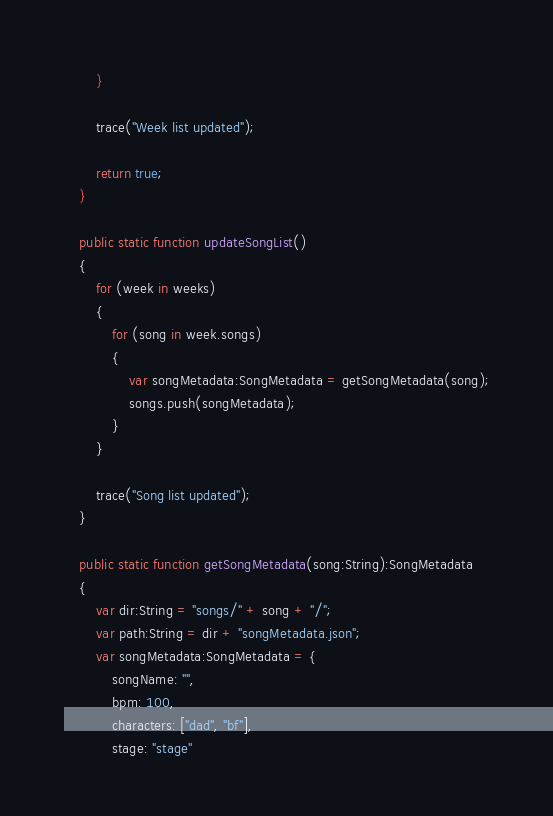Convert code to text. <code><loc_0><loc_0><loc_500><loc_500><_Haxe_>		}

		trace("Week list updated");

		return true;
	}

	public static function updateSongList()
	{
		for (week in weeks)
		{
			for (song in week.songs)
			{
				var songMetadata:SongMetadata = getSongMetadata(song);
				songs.push(songMetadata);
			}
		}

		trace("Song list updated");
	}

	public static function getSongMetadata(song:String):SongMetadata
	{
		var dir:String = "songs/" + song + "/";
		var path:String = dir + "songMetadata.json";
		var songMetadata:SongMetadata = {
			songName: "",
			bpm: 100,
			characters: ["dad", "bf"],
			stage: "stage"</code> 